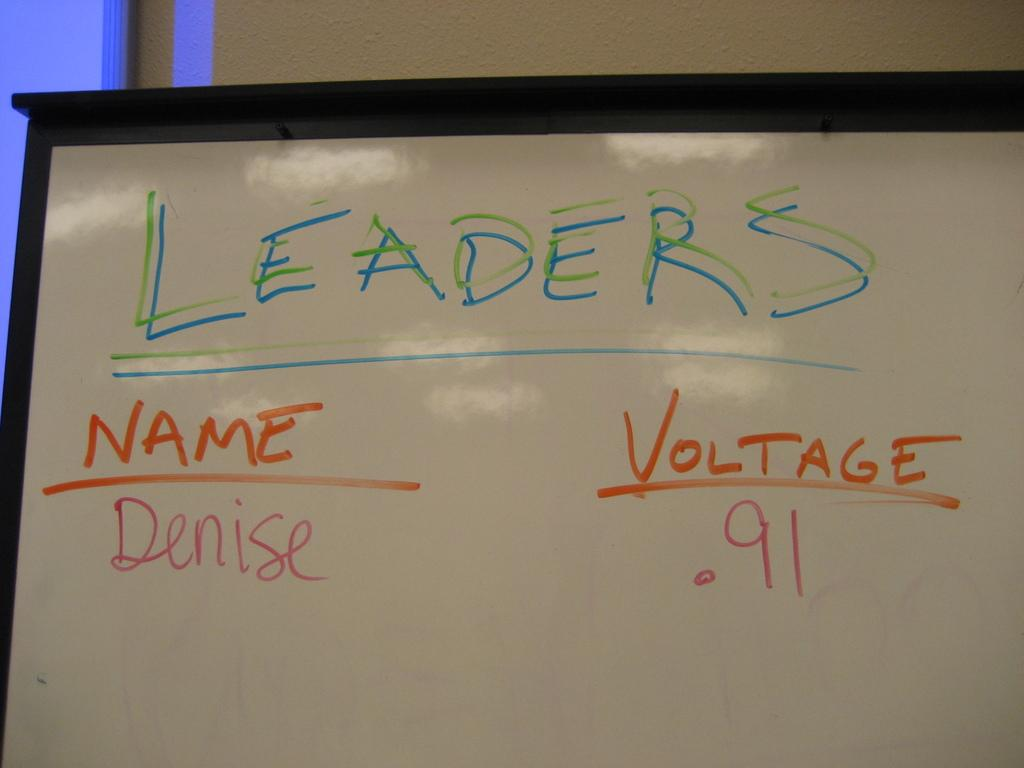<image>
Render a clear and concise summary of the photo. A whiteboard displays that Denise is one of the leaders with .91 voltage. 